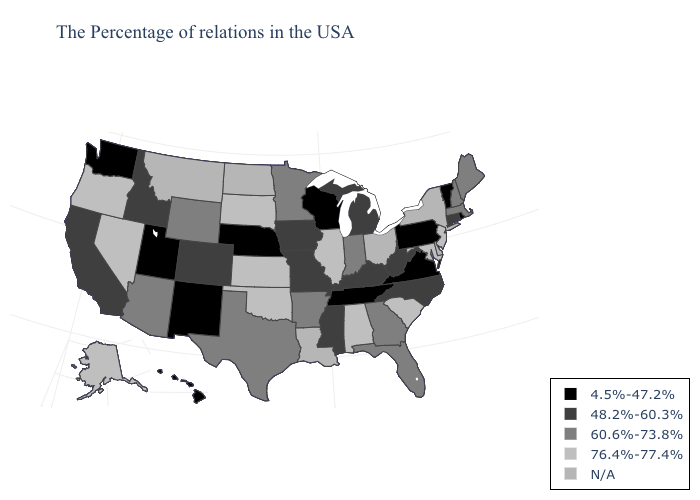What is the value of Kentucky?
Give a very brief answer. 48.2%-60.3%. What is the value of Minnesota?
Quick response, please. 60.6%-73.8%. Name the states that have a value in the range 60.6%-73.8%?
Give a very brief answer. Maine, Massachusetts, New Hampshire, Florida, Georgia, Indiana, Arkansas, Minnesota, Texas, Wyoming, Arizona. What is the highest value in states that border Wisconsin?
Keep it brief. 76.4%-77.4%. What is the highest value in states that border Oklahoma?
Quick response, please. 76.4%-77.4%. What is the highest value in the USA?
Write a very short answer. 76.4%-77.4%. Name the states that have a value in the range N/A?
Quick response, please. New York, Delaware, Ohio, Louisiana, North Dakota, Montana. Name the states that have a value in the range N/A?
Keep it brief. New York, Delaware, Ohio, Louisiana, North Dakota, Montana. What is the lowest value in states that border Rhode Island?
Short answer required. 48.2%-60.3%. Does Alabama have the lowest value in the USA?
Answer briefly. No. Does the first symbol in the legend represent the smallest category?
Answer briefly. Yes. Name the states that have a value in the range N/A?
Write a very short answer. New York, Delaware, Ohio, Louisiana, North Dakota, Montana. What is the value of North Dakota?
Short answer required. N/A. 